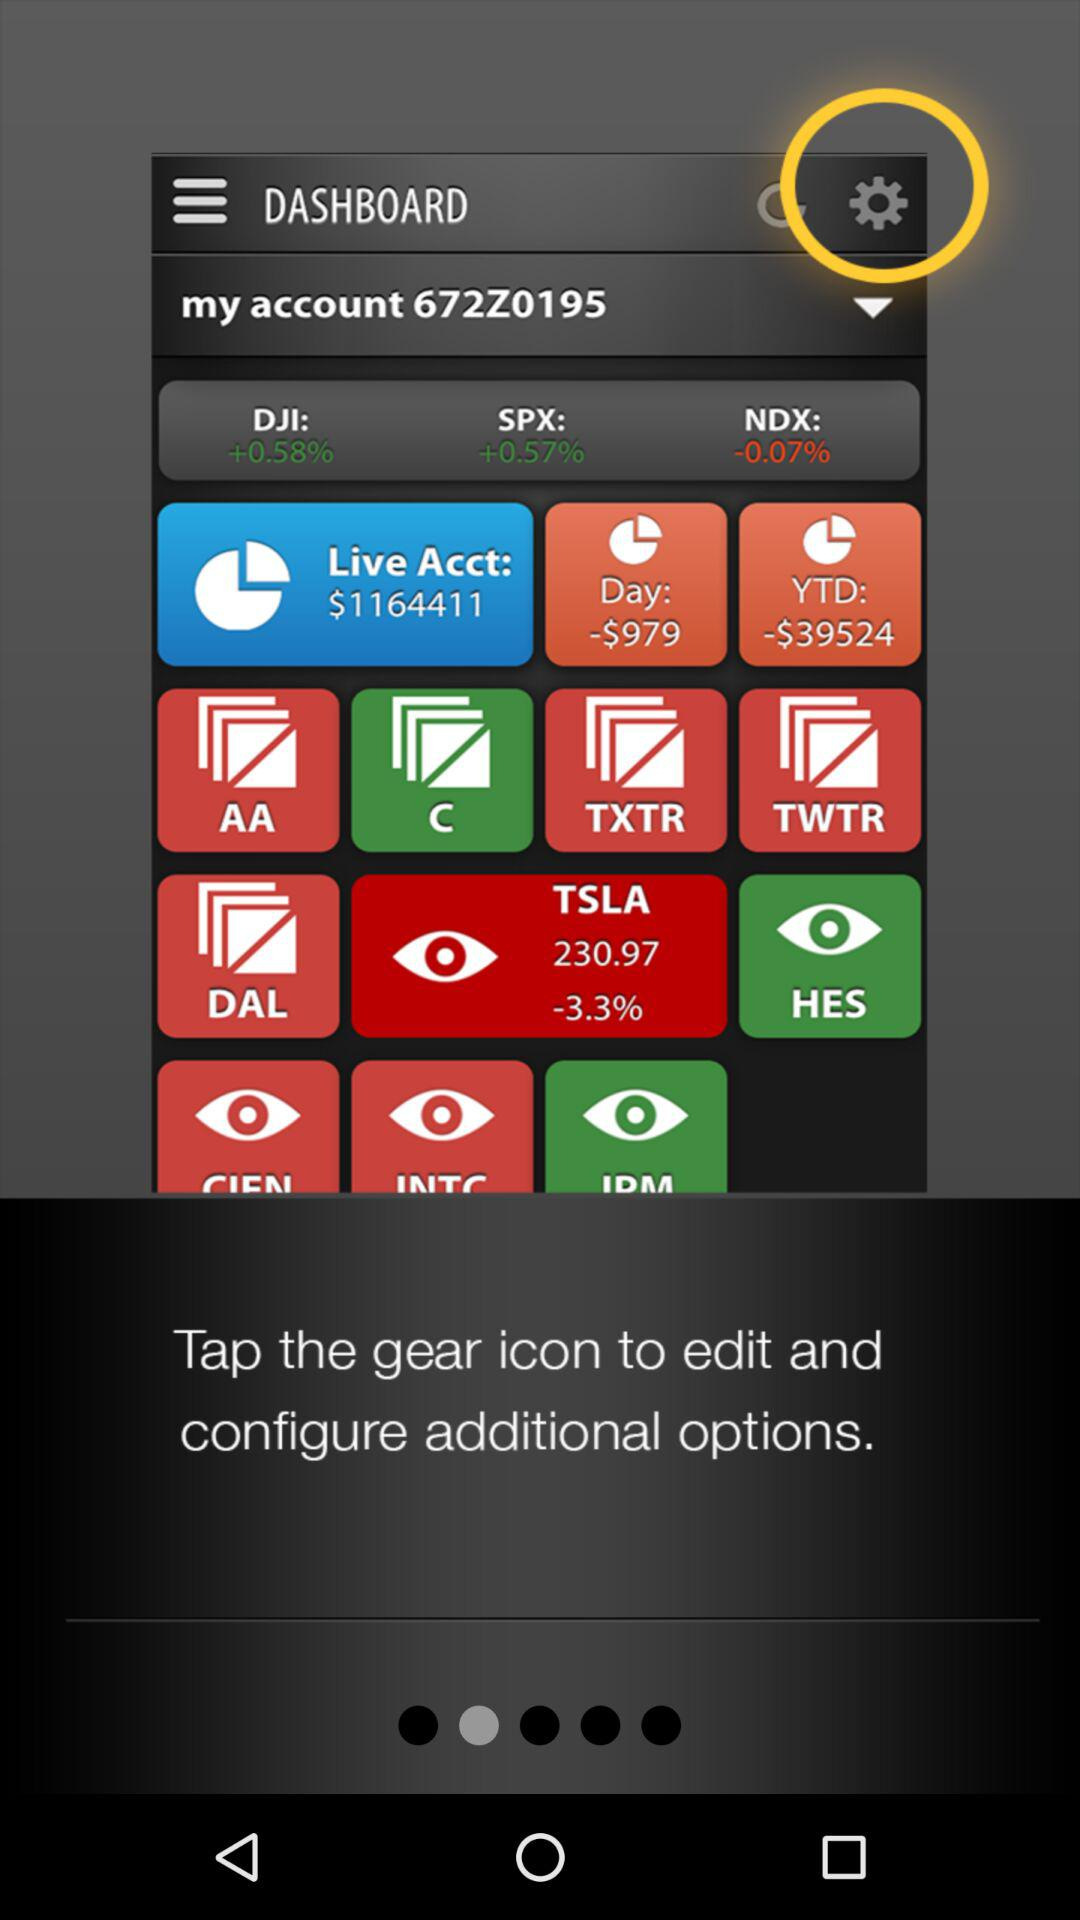How much was TSLA at yesterday's closing?
When the provided information is insufficient, respond with <no answer>. <no answer> 